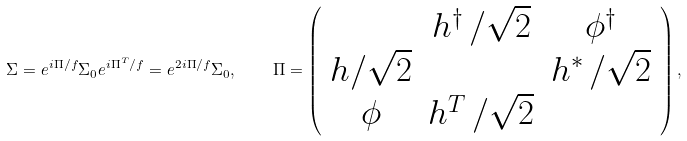Convert formula to latex. <formula><loc_0><loc_0><loc_500><loc_500>\Sigma = e ^ { i \Pi / f } \Sigma _ { 0 } e ^ { i \Pi ^ { T } / f } = e ^ { 2 i \Pi / f } \Sigma _ { 0 } , \quad \Pi = \left ( \begin{array} { c c c } & h ^ { \dagger } \, / \sqrt { 2 } & \phi ^ { \dagger } \\ h / \sqrt { 2 } & & h ^ { \ast } \, / \sqrt { 2 } \\ \phi & h ^ { T } \, / \sqrt { 2 } & \end{array} \right ) ,</formula> 